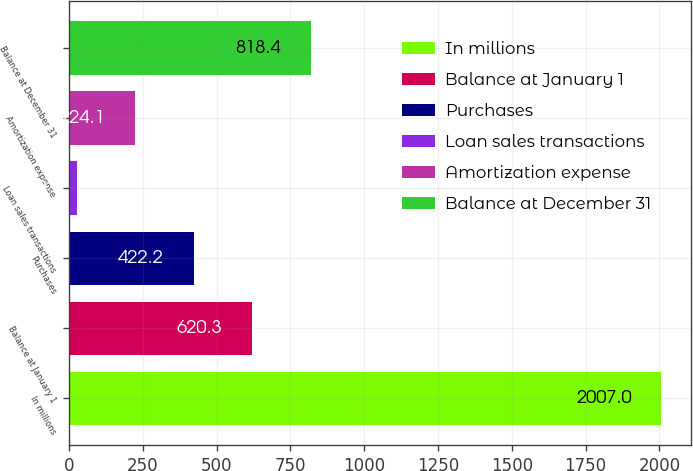Convert chart. <chart><loc_0><loc_0><loc_500><loc_500><bar_chart><fcel>In millions<fcel>Balance at January 1<fcel>Purchases<fcel>Loan sales transactions<fcel>Amortization expense<fcel>Balance at December 31<nl><fcel>2007<fcel>620.3<fcel>422.2<fcel>26<fcel>224.1<fcel>818.4<nl></chart> 